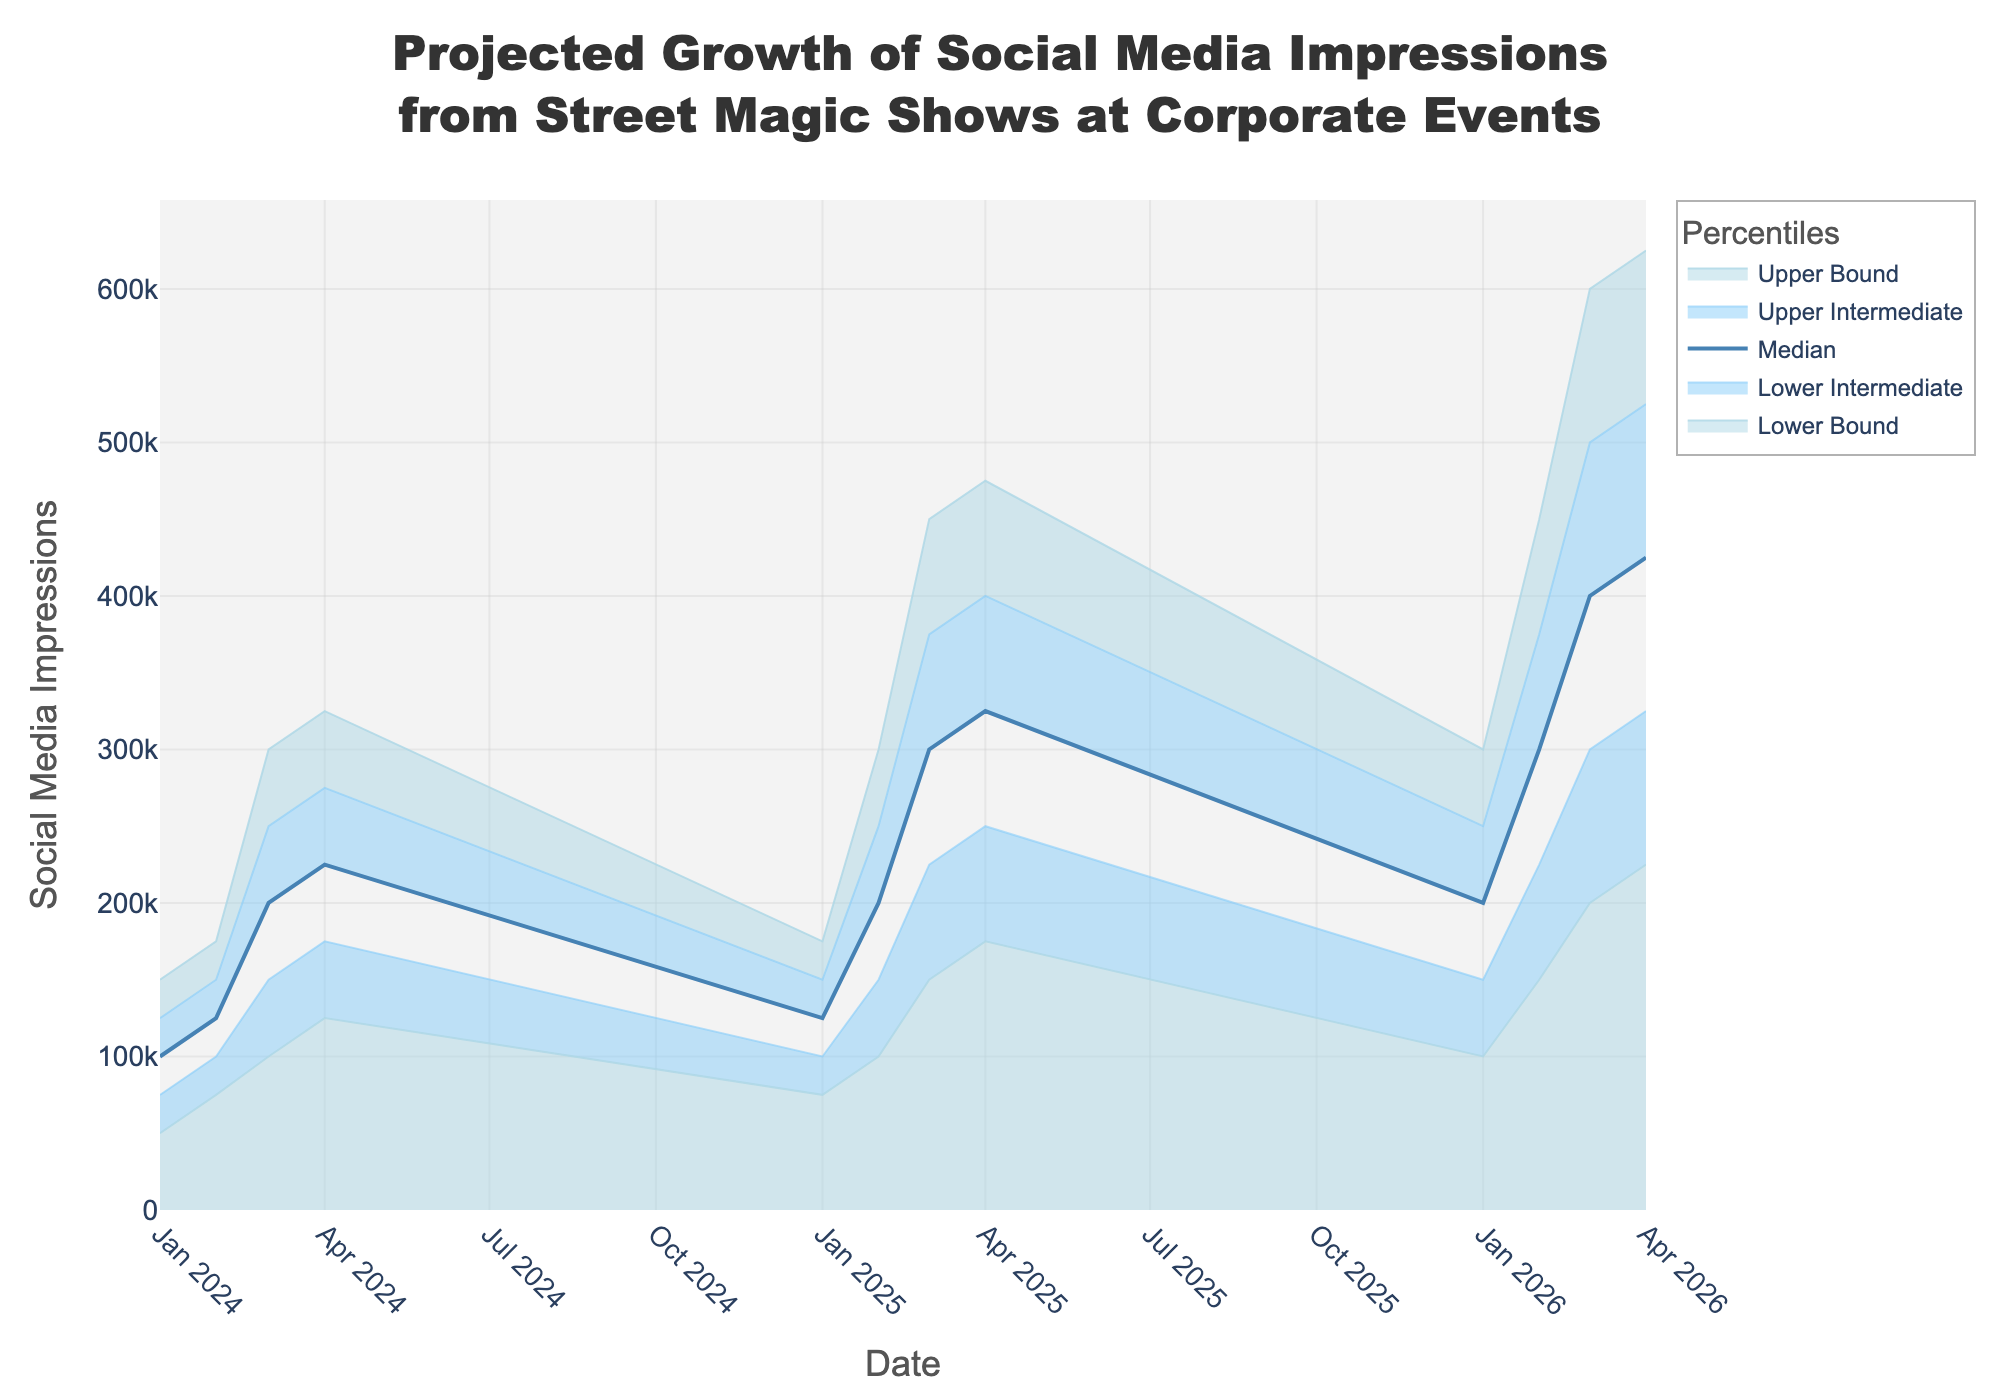What's the title of the figure? The title is located at the top of the figure, and it describes the overall content being displayed.
Answer: Projected Growth of Social Media Impressions from Street Magic Shows at Corporate Events What is the median projected social media impression for Q3 2025? The median value for Q3 2025 is indicated by the central line for the percentile 'Median' for that specific quarter.
Answer: 300,000 During which quarter and year is the upper bound closest to 300,000 impressions? By visually inspecting the upper bound values charted, one can see that Q1 2026's upper bound is 300,000 impressions.
Answer: Q1 2026 How much do the median social media impressions increase from Q1 2024 to Q4 2024? By subtracting the median value of Q1 2024 (100,000) from the median value of Q4 2024 (225,000), we can determine the increase.
Answer: 125,000 Which quarter shows the maximum growth in the upper bound from the previous quarter? By comparing the quarter-to-quarter growth in the upper bound, Q3 2025 (450,000) from Q2 2025 (300,000) indicates the greatest increase.
Answer: Q3 2025 Compare the lower intermediate social media impressions between Q1 2024 and Q1 2025. Which one is higher? By comparing the lower intermediate values, Q1 2025 (100,000) is higher than Q1 2024 (75,000).
Answer: Q1 2025 How does the range between the upper bound and the lower bound change from Q2 2024 to Q4 2024? By comparing the range for Q2 2024 (175,000 from 75,000) to Q4 2024 (325,000 from 125,000), one can observe the change in the difference.
Answer: Increase by 50,000 What is the projected social media impression range for Q3 2026? The range can be calculated by subtracting the lower bound (200,000) from the upper bound (600,000) for Q3 2026.
Answer: 400,000 Which quarter in 2025 shows the highest median projected social media impressions? By comparing the median values for all quarters in 2025, Q4 2025 has the highest median projection with 325,000.
Answer: Q4 2025 What's the difference between the upper intermediate and lower intermediate in Q4 2026? By subtracting the lower intermediate value (325,000) from the upper intermediate value (525,000) for Q4 2026, the difference is determined.
Answer: 200,000 